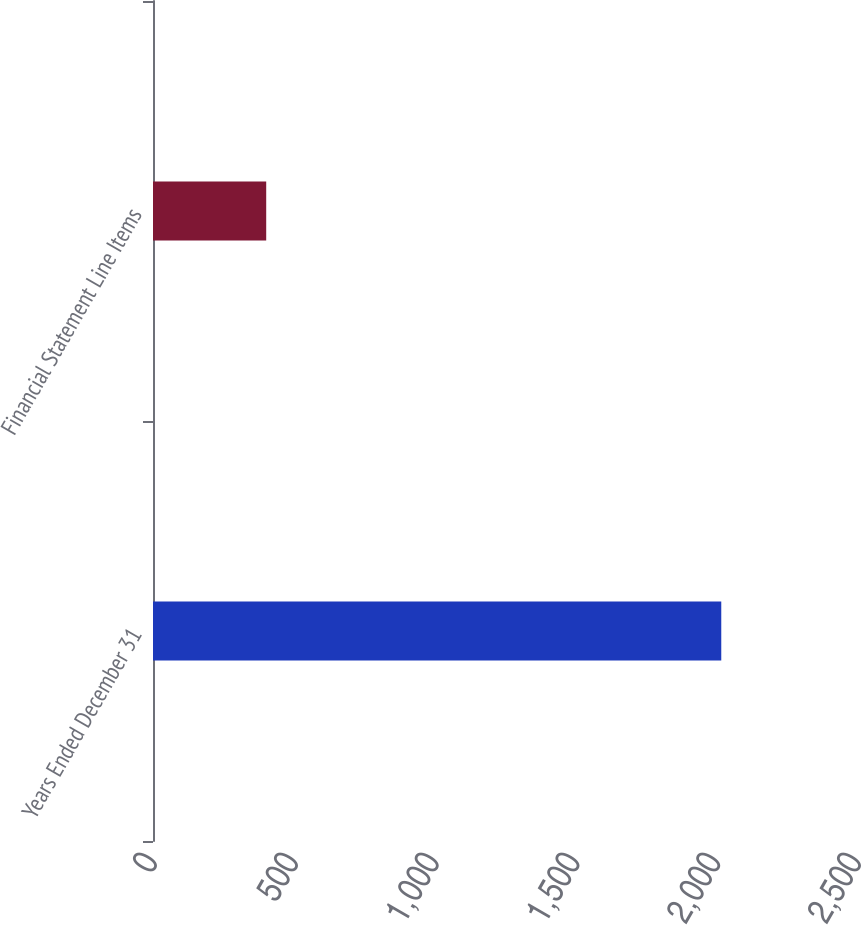<chart> <loc_0><loc_0><loc_500><loc_500><bar_chart><fcel>Years Ended December 31<fcel>Financial Statement Line Items<nl><fcel>2018<fcel>402<nl></chart> 